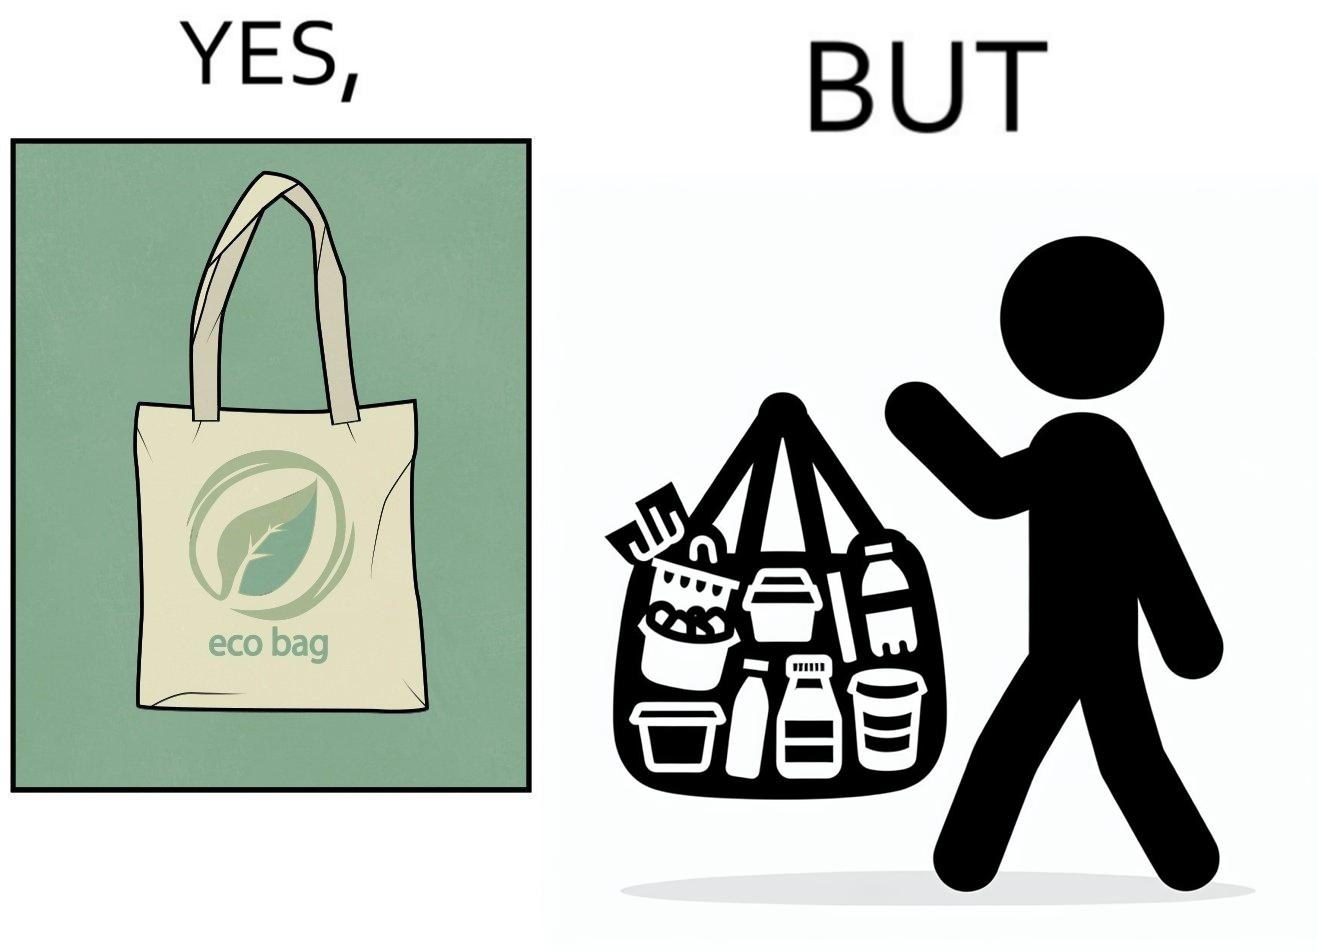Describe the content of this image. The image is ironic, because people nowadays use eco-bag thinking them as safe for the environment but in turn use products which are harmful for the environment or are packaged in some non-biodegradable material 